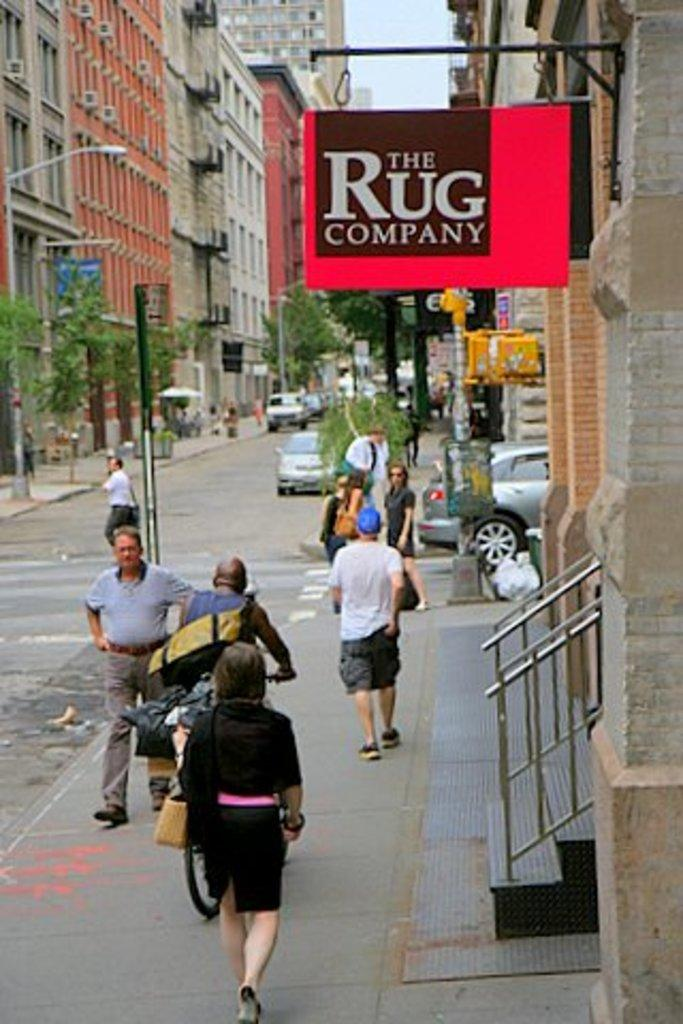How many people are in the group visible in the image? There is a group of people standing in the image, but the exact number cannot be determined from the provided facts. What type of vehicles can be seen on the road in the image? Vehicles are present on the road in the image, but their specific types cannot be determined from the provided facts. What type of vegetation is present in the image? Trees are visible in the image. What type of structures are present in the image? Poles, boards, and buildings are present in the image. What is visible in the sky in the image? The sky is visible in the image, but no specific details about its appearance can be determined from the provided facts. Is there any blood visible on the people in the image? There is no mention of blood or any injuries in the provided facts, so it cannot be determined if blood is visible in the image. What type of game is being played by the people in the image? There is no indication of a game being played in the image, so it cannot be determined what type of game might be in progress. 